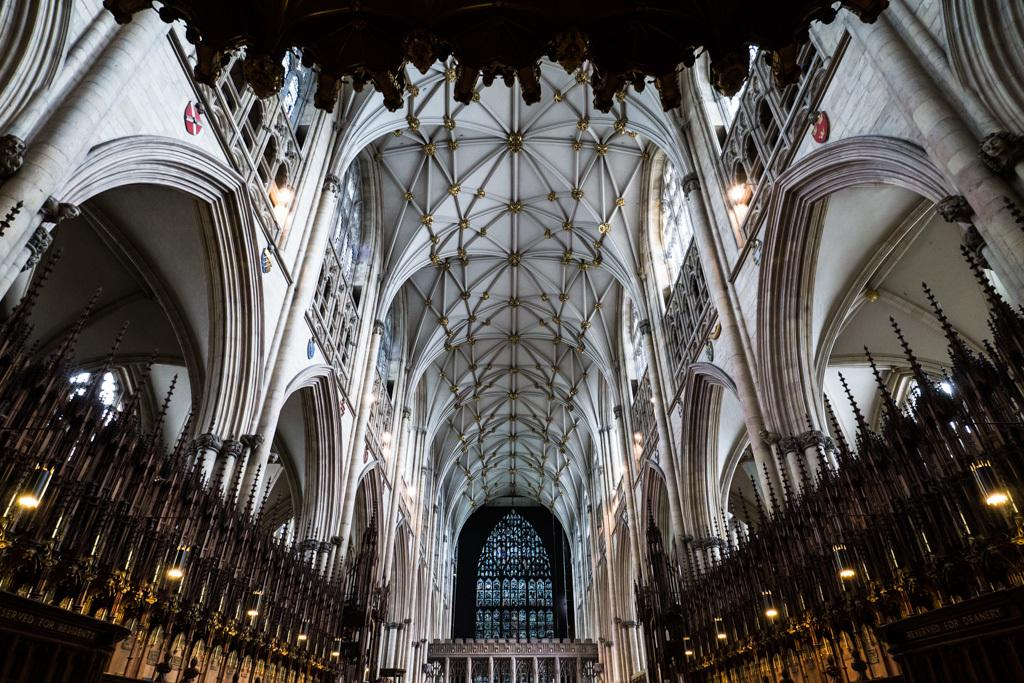What type of building is shown in the image? The image is an inner view of a church. What can be seen illuminating the interior of the church? There are lights visible in the image. What architectural features are present in the image? There are pillars in the image. What part of the church's structure is visible in the image? The ceiling is visible in the image. What type of creature can be seen climbing the pillars in the image? There is no creature present in the image; it is an inner view of a church with no visible creatures. What type of sail is visible in the image? There is no sail present in the image; it is an interior view of a church with no nautical elements. 